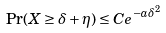<formula> <loc_0><loc_0><loc_500><loc_500>\Pr ( X \geq \delta + \eta ) \leq C e ^ { - a \delta ^ { 2 } }</formula> 